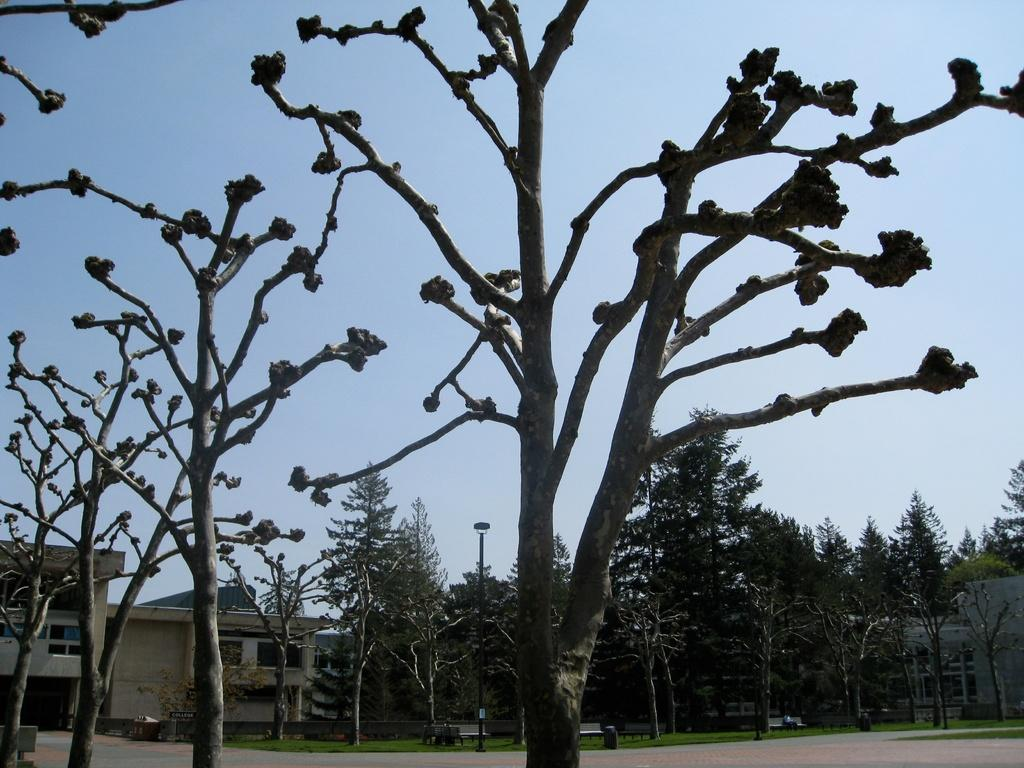What type of vegetation can be seen in the image? There are trees in the image. What type of structures are present in the image? There are buildings with windows in the image. What feature do the buildings have? The buildings have windows. What type of seating is available in the image? There are benches in the image. What type of path is visible in the image? There is a path in the image. What type of ground cover is present in the image? There is grass in the image. What type of vertical structure is present in the image? There is a pole in the image. Is there anyone sitting on the benches in the image? Yes, there is a person sitting on a bench in the image. What can be seen in the background of the image? The sky is visible in the background of the image. What is the price of the soda being sold at the pole in the image? There is no soda or pole selling soda present in the image. What type of view can be seen from the person sitting on the bench in the image? The image does not provide enough information to determine the view from the person's perspective. 